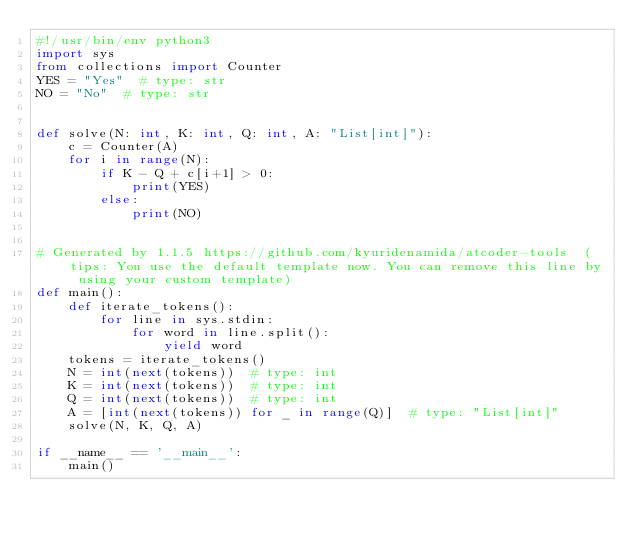<code> <loc_0><loc_0><loc_500><loc_500><_Python_>#!/usr/bin/env python3
import sys
from collections import Counter
YES = "Yes"  # type: str
NO = "No"  # type: str


def solve(N: int, K: int, Q: int, A: "List[int]"):
    c = Counter(A)
    for i in range(N):
        if K - Q + c[i+1] > 0:
            print(YES)
        else:
            print(NO)


# Generated by 1.1.5 https://github.com/kyuridenamida/atcoder-tools  (tips: You use the default template now. You can remove this line by using your custom template)
def main():
    def iterate_tokens():
        for line in sys.stdin:
            for word in line.split():
                yield word
    tokens = iterate_tokens()
    N = int(next(tokens))  # type: int
    K = int(next(tokens))  # type: int
    Q = int(next(tokens))  # type: int
    A = [int(next(tokens)) for _ in range(Q)]  # type: "List[int]"
    solve(N, K, Q, A)

if __name__ == '__main__':
    main()
</code> 